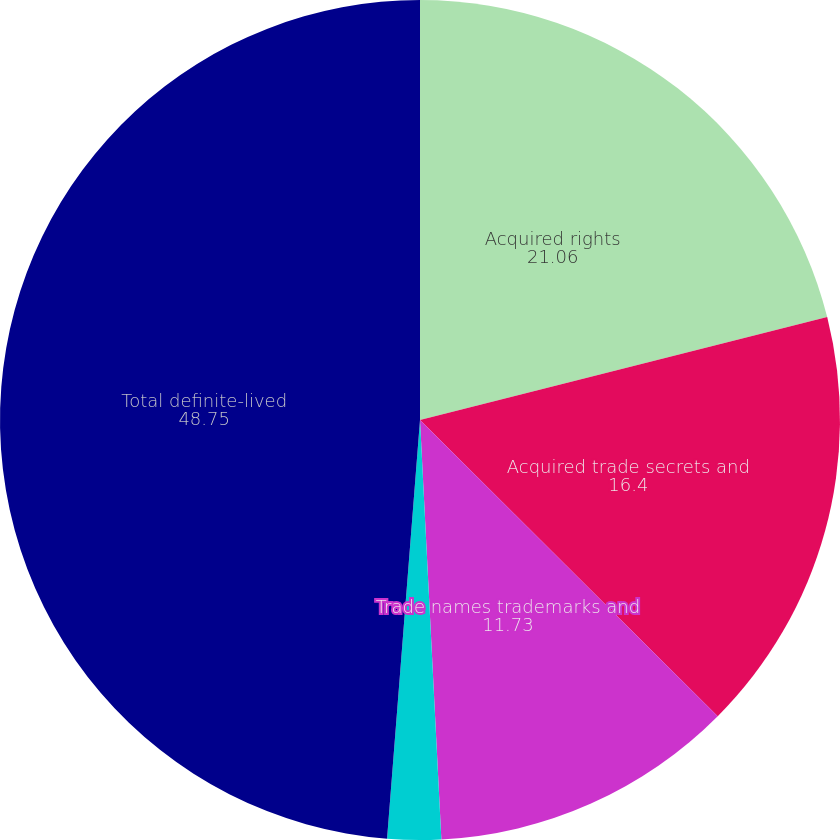<chart> <loc_0><loc_0><loc_500><loc_500><pie_chart><fcel>Acquired rights<fcel>Acquired trade secrets and<fcel>Trade names trademarks and<fcel>Other definite-lived<fcel>Total definite-lived<nl><fcel>21.06%<fcel>16.4%<fcel>11.73%<fcel>2.06%<fcel>48.75%<nl></chart> 